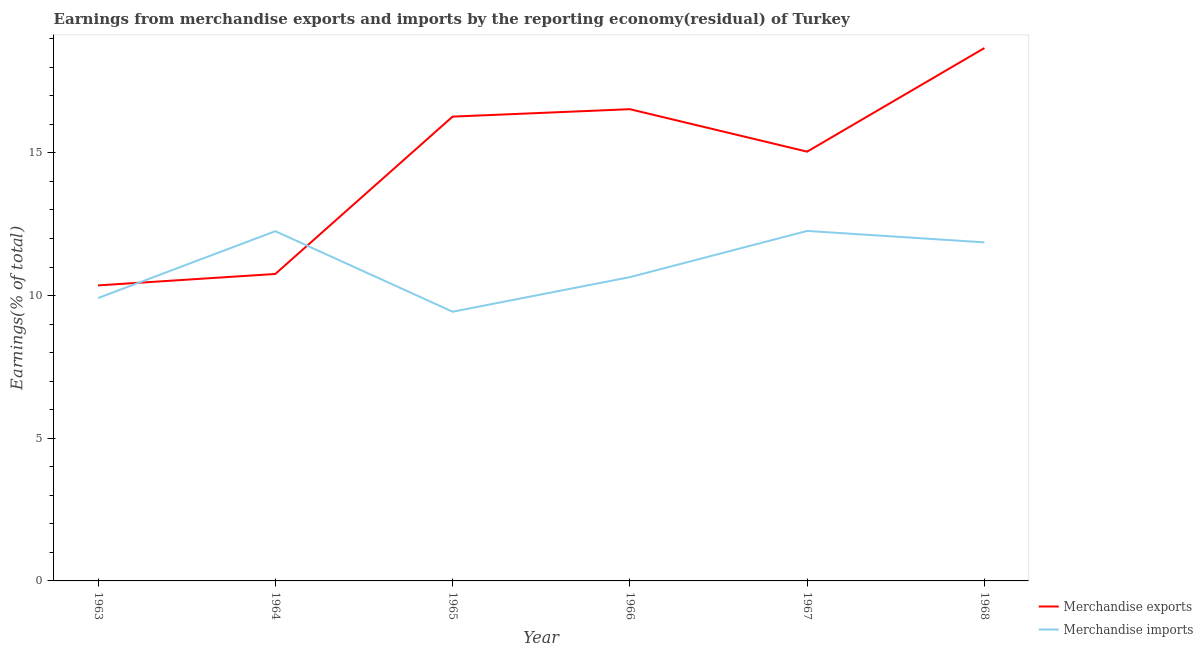How many different coloured lines are there?
Provide a short and direct response. 2. Does the line corresponding to earnings from merchandise imports intersect with the line corresponding to earnings from merchandise exports?
Offer a very short reply. Yes. What is the earnings from merchandise exports in 1964?
Make the answer very short. 10.76. Across all years, what is the maximum earnings from merchandise exports?
Your response must be concise. 18.67. Across all years, what is the minimum earnings from merchandise imports?
Offer a very short reply. 9.43. In which year was the earnings from merchandise imports maximum?
Ensure brevity in your answer.  1967. What is the total earnings from merchandise exports in the graph?
Give a very brief answer. 87.63. What is the difference between the earnings from merchandise imports in 1963 and that in 1967?
Your answer should be very brief. -2.35. What is the difference between the earnings from merchandise exports in 1964 and the earnings from merchandise imports in 1963?
Your response must be concise. 0.85. What is the average earnings from merchandise exports per year?
Offer a terse response. 14.61. In the year 1968, what is the difference between the earnings from merchandise exports and earnings from merchandise imports?
Give a very brief answer. 6.81. What is the ratio of the earnings from merchandise imports in 1964 to that in 1965?
Provide a succinct answer. 1.3. What is the difference between the highest and the second highest earnings from merchandise imports?
Provide a short and direct response. 0.01. What is the difference between the highest and the lowest earnings from merchandise exports?
Your answer should be very brief. 8.32. In how many years, is the earnings from merchandise imports greater than the average earnings from merchandise imports taken over all years?
Make the answer very short. 3. Does the earnings from merchandise exports monotonically increase over the years?
Offer a very short reply. No. How many lines are there?
Provide a succinct answer. 2. How many years are there in the graph?
Offer a terse response. 6. Does the graph contain any zero values?
Make the answer very short. No. Where does the legend appear in the graph?
Your answer should be compact. Bottom right. How are the legend labels stacked?
Your response must be concise. Vertical. What is the title of the graph?
Your answer should be compact. Earnings from merchandise exports and imports by the reporting economy(residual) of Turkey. Does "Money lenders" appear as one of the legend labels in the graph?
Your response must be concise. No. What is the label or title of the X-axis?
Your answer should be compact. Year. What is the label or title of the Y-axis?
Your response must be concise. Earnings(% of total). What is the Earnings(% of total) of Merchandise exports in 1963?
Provide a succinct answer. 10.36. What is the Earnings(% of total) in Merchandise imports in 1963?
Provide a succinct answer. 9.91. What is the Earnings(% of total) of Merchandise exports in 1964?
Your response must be concise. 10.76. What is the Earnings(% of total) of Merchandise imports in 1964?
Offer a terse response. 12.26. What is the Earnings(% of total) of Merchandise exports in 1965?
Your response must be concise. 16.27. What is the Earnings(% of total) in Merchandise imports in 1965?
Your answer should be very brief. 9.43. What is the Earnings(% of total) of Merchandise exports in 1966?
Give a very brief answer. 16.53. What is the Earnings(% of total) of Merchandise imports in 1966?
Ensure brevity in your answer.  10.64. What is the Earnings(% of total) in Merchandise exports in 1967?
Your answer should be very brief. 15.04. What is the Earnings(% of total) in Merchandise imports in 1967?
Provide a short and direct response. 12.26. What is the Earnings(% of total) in Merchandise exports in 1968?
Provide a succinct answer. 18.67. What is the Earnings(% of total) of Merchandise imports in 1968?
Offer a very short reply. 11.86. Across all years, what is the maximum Earnings(% of total) in Merchandise exports?
Your answer should be compact. 18.67. Across all years, what is the maximum Earnings(% of total) of Merchandise imports?
Offer a terse response. 12.26. Across all years, what is the minimum Earnings(% of total) of Merchandise exports?
Your response must be concise. 10.36. Across all years, what is the minimum Earnings(% of total) of Merchandise imports?
Make the answer very short. 9.43. What is the total Earnings(% of total) of Merchandise exports in the graph?
Provide a short and direct response. 87.63. What is the total Earnings(% of total) of Merchandise imports in the graph?
Your response must be concise. 66.37. What is the difference between the Earnings(% of total) in Merchandise exports in 1963 and that in 1964?
Provide a succinct answer. -0.4. What is the difference between the Earnings(% of total) of Merchandise imports in 1963 and that in 1964?
Your answer should be compact. -2.34. What is the difference between the Earnings(% of total) in Merchandise exports in 1963 and that in 1965?
Offer a terse response. -5.91. What is the difference between the Earnings(% of total) in Merchandise imports in 1963 and that in 1965?
Give a very brief answer. 0.48. What is the difference between the Earnings(% of total) in Merchandise exports in 1963 and that in 1966?
Your answer should be compact. -6.17. What is the difference between the Earnings(% of total) in Merchandise imports in 1963 and that in 1966?
Make the answer very short. -0.73. What is the difference between the Earnings(% of total) in Merchandise exports in 1963 and that in 1967?
Provide a short and direct response. -4.69. What is the difference between the Earnings(% of total) in Merchandise imports in 1963 and that in 1967?
Offer a very short reply. -2.35. What is the difference between the Earnings(% of total) in Merchandise exports in 1963 and that in 1968?
Keep it short and to the point. -8.32. What is the difference between the Earnings(% of total) in Merchandise imports in 1963 and that in 1968?
Keep it short and to the point. -1.95. What is the difference between the Earnings(% of total) of Merchandise exports in 1964 and that in 1965?
Give a very brief answer. -5.51. What is the difference between the Earnings(% of total) of Merchandise imports in 1964 and that in 1965?
Ensure brevity in your answer.  2.82. What is the difference between the Earnings(% of total) of Merchandise exports in 1964 and that in 1966?
Provide a succinct answer. -5.77. What is the difference between the Earnings(% of total) in Merchandise imports in 1964 and that in 1966?
Provide a succinct answer. 1.61. What is the difference between the Earnings(% of total) in Merchandise exports in 1964 and that in 1967?
Ensure brevity in your answer.  -4.29. What is the difference between the Earnings(% of total) of Merchandise imports in 1964 and that in 1967?
Offer a terse response. -0.01. What is the difference between the Earnings(% of total) of Merchandise exports in 1964 and that in 1968?
Provide a succinct answer. -7.92. What is the difference between the Earnings(% of total) of Merchandise imports in 1964 and that in 1968?
Provide a short and direct response. 0.39. What is the difference between the Earnings(% of total) in Merchandise exports in 1965 and that in 1966?
Make the answer very short. -0.26. What is the difference between the Earnings(% of total) in Merchandise imports in 1965 and that in 1966?
Offer a very short reply. -1.21. What is the difference between the Earnings(% of total) of Merchandise exports in 1965 and that in 1967?
Offer a terse response. 1.23. What is the difference between the Earnings(% of total) of Merchandise imports in 1965 and that in 1967?
Provide a succinct answer. -2.83. What is the difference between the Earnings(% of total) in Merchandise exports in 1965 and that in 1968?
Keep it short and to the point. -2.4. What is the difference between the Earnings(% of total) in Merchandise imports in 1965 and that in 1968?
Provide a short and direct response. -2.43. What is the difference between the Earnings(% of total) of Merchandise exports in 1966 and that in 1967?
Offer a very short reply. 1.49. What is the difference between the Earnings(% of total) in Merchandise imports in 1966 and that in 1967?
Your answer should be compact. -1.62. What is the difference between the Earnings(% of total) of Merchandise exports in 1966 and that in 1968?
Make the answer very short. -2.14. What is the difference between the Earnings(% of total) of Merchandise imports in 1966 and that in 1968?
Make the answer very short. -1.22. What is the difference between the Earnings(% of total) in Merchandise exports in 1967 and that in 1968?
Keep it short and to the point. -3.63. What is the difference between the Earnings(% of total) of Merchandise imports in 1967 and that in 1968?
Provide a short and direct response. 0.4. What is the difference between the Earnings(% of total) in Merchandise exports in 1963 and the Earnings(% of total) in Merchandise imports in 1964?
Offer a terse response. -1.9. What is the difference between the Earnings(% of total) in Merchandise exports in 1963 and the Earnings(% of total) in Merchandise imports in 1965?
Your answer should be compact. 0.92. What is the difference between the Earnings(% of total) in Merchandise exports in 1963 and the Earnings(% of total) in Merchandise imports in 1966?
Your answer should be very brief. -0.29. What is the difference between the Earnings(% of total) in Merchandise exports in 1963 and the Earnings(% of total) in Merchandise imports in 1967?
Provide a short and direct response. -1.91. What is the difference between the Earnings(% of total) in Merchandise exports in 1963 and the Earnings(% of total) in Merchandise imports in 1968?
Keep it short and to the point. -1.51. What is the difference between the Earnings(% of total) in Merchandise exports in 1964 and the Earnings(% of total) in Merchandise imports in 1965?
Your answer should be compact. 1.32. What is the difference between the Earnings(% of total) in Merchandise exports in 1964 and the Earnings(% of total) in Merchandise imports in 1966?
Offer a terse response. 0.11. What is the difference between the Earnings(% of total) of Merchandise exports in 1964 and the Earnings(% of total) of Merchandise imports in 1967?
Make the answer very short. -1.51. What is the difference between the Earnings(% of total) of Merchandise exports in 1964 and the Earnings(% of total) of Merchandise imports in 1968?
Make the answer very short. -1.11. What is the difference between the Earnings(% of total) of Merchandise exports in 1965 and the Earnings(% of total) of Merchandise imports in 1966?
Your answer should be compact. 5.63. What is the difference between the Earnings(% of total) in Merchandise exports in 1965 and the Earnings(% of total) in Merchandise imports in 1967?
Your answer should be very brief. 4.01. What is the difference between the Earnings(% of total) in Merchandise exports in 1965 and the Earnings(% of total) in Merchandise imports in 1968?
Offer a terse response. 4.41. What is the difference between the Earnings(% of total) of Merchandise exports in 1966 and the Earnings(% of total) of Merchandise imports in 1967?
Provide a short and direct response. 4.27. What is the difference between the Earnings(% of total) of Merchandise exports in 1966 and the Earnings(% of total) of Merchandise imports in 1968?
Provide a short and direct response. 4.67. What is the difference between the Earnings(% of total) of Merchandise exports in 1967 and the Earnings(% of total) of Merchandise imports in 1968?
Offer a terse response. 3.18. What is the average Earnings(% of total) of Merchandise exports per year?
Make the answer very short. 14.61. What is the average Earnings(% of total) of Merchandise imports per year?
Your answer should be very brief. 11.06. In the year 1963, what is the difference between the Earnings(% of total) in Merchandise exports and Earnings(% of total) in Merchandise imports?
Keep it short and to the point. 0.44. In the year 1964, what is the difference between the Earnings(% of total) in Merchandise exports and Earnings(% of total) in Merchandise imports?
Provide a short and direct response. -1.5. In the year 1965, what is the difference between the Earnings(% of total) in Merchandise exports and Earnings(% of total) in Merchandise imports?
Your response must be concise. 6.84. In the year 1966, what is the difference between the Earnings(% of total) of Merchandise exports and Earnings(% of total) of Merchandise imports?
Provide a short and direct response. 5.89. In the year 1967, what is the difference between the Earnings(% of total) of Merchandise exports and Earnings(% of total) of Merchandise imports?
Offer a very short reply. 2.78. In the year 1968, what is the difference between the Earnings(% of total) in Merchandise exports and Earnings(% of total) in Merchandise imports?
Offer a very short reply. 6.81. What is the ratio of the Earnings(% of total) in Merchandise exports in 1963 to that in 1964?
Your answer should be compact. 0.96. What is the ratio of the Earnings(% of total) in Merchandise imports in 1963 to that in 1964?
Make the answer very short. 0.81. What is the ratio of the Earnings(% of total) in Merchandise exports in 1963 to that in 1965?
Provide a succinct answer. 0.64. What is the ratio of the Earnings(% of total) of Merchandise imports in 1963 to that in 1965?
Offer a terse response. 1.05. What is the ratio of the Earnings(% of total) in Merchandise exports in 1963 to that in 1966?
Keep it short and to the point. 0.63. What is the ratio of the Earnings(% of total) of Merchandise imports in 1963 to that in 1966?
Make the answer very short. 0.93. What is the ratio of the Earnings(% of total) in Merchandise exports in 1963 to that in 1967?
Offer a very short reply. 0.69. What is the ratio of the Earnings(% of total) of Merchandise imports in 1963 to that in 1967?
Your answer should be compact. 0.81. What is the ratio of the Earnings(% of total) in Merchandise exports in 1963 to that in 1968?
Offer a very short reply. 0.55. What is the ratio of the Earnings(% of total) in Merchandise imports in 1963 to that in 1968?
Keep it short and to the point. 0.84. What is the ratio of the Earnings(% of total) in Merchandise exports in 1964 to that in 1965?
Provide a succinct answer. 0.66. What is the ratio of the Earnings(% of total) in Merchandise imports in 1964 to that in 1965?
Provide a short and direct response. 1.3. What is the ratio of the Earnings(% of total) in Merchandise exports in 1964 to that in 1966?
Provide a succinct answer. 0.65. What is the ratio of the Earnings(% of total) of Merchandise imports in 1964 to that in 1966?
Keep it short and to the point. 1.15. What is the ratio of the Earnings(% of total) of Merchandise exports in 1964 to that in 1967?
Give a very brief answer. 0.72. What is the ratio of the Earnings(% of total) of Merchandise exports in 1964 to that in 1968?
Ensure brevity in your answer.  0.58. What is the ratio of the Earnings(% of total) of Merchandise imports in 1964 to that in 1968?
Ensure brevity in your answer.  1.03. What is the ratio of the Earnings(% of total) of Merchandise exports in 1965 to that in 1966?
Keep it short and to the point. 0.98. What is the ratio of the Earnings(% of total) in Merchandise imports in 1965 to that in 1966?
Your response must be concise. 0.89. What is the ratio of the Earnings(% of total) of Merchandise exports in 1965 to that in 1967?
Your answer should be compact. 1.08. What is the ratio of the Earnings(% of total) of Merchandise imports in 1965 to that in 1967?
Offer a terse response. 0.77. What is the ratio of the Earnings(% of total) of Merchandise exports in 1965 to that in 1968?
Provide a succinct answer. 0.87. What is the ratio of the Earnings(% of total) in Merchandise imports in 1965 to that in 1968?
Offer a terse response. 0.8. What is the ratio of the Earnings(% of total) in Merchandise exports in 1966 to that in 1967?
Your response must be concise. 1.1. What is the ratio of the Earnings(% of total) of Merchandise imports in 1966 to that in 1967?
Keep it short and to the point. 0.87. What is the ratio of the Earnings(% of total) in Merchandise exports in 1966 to that in 1968?
Your response must be concise. 0.89. What is the ratio of the Earnings(% of total) of Merchandise imports in 1966 to that in 1968?
Your answer should be very brief. 0.9. What is the ratio of the Earnings(% of total) in Merchandise exports in 1967 to that in 1968?
Give a very brief answer. 0.81. What is the ratio of the Earnings(% of total) of Merchandise imports in 1967 to that in 1968?
Your response must be concise. 1.03. What is the difference between the highest and the second highest Earnings(% of total) in Merchandise exports?
Ensure brevity in your answer.  2.14. What is the difference between the highest and the second highest Earnings(% of total) of Merchandise imports?
Give a very brief answer. 0.01. What is the difference between the highest and the lowest Earnings(% of total) in Merchandise exports?
Provide a short and direct response. 8.32. What is the difference between the highest and the lowest Earnings(% of total) of Merchandise imports?
Keep it short and to the point. 2.83. 